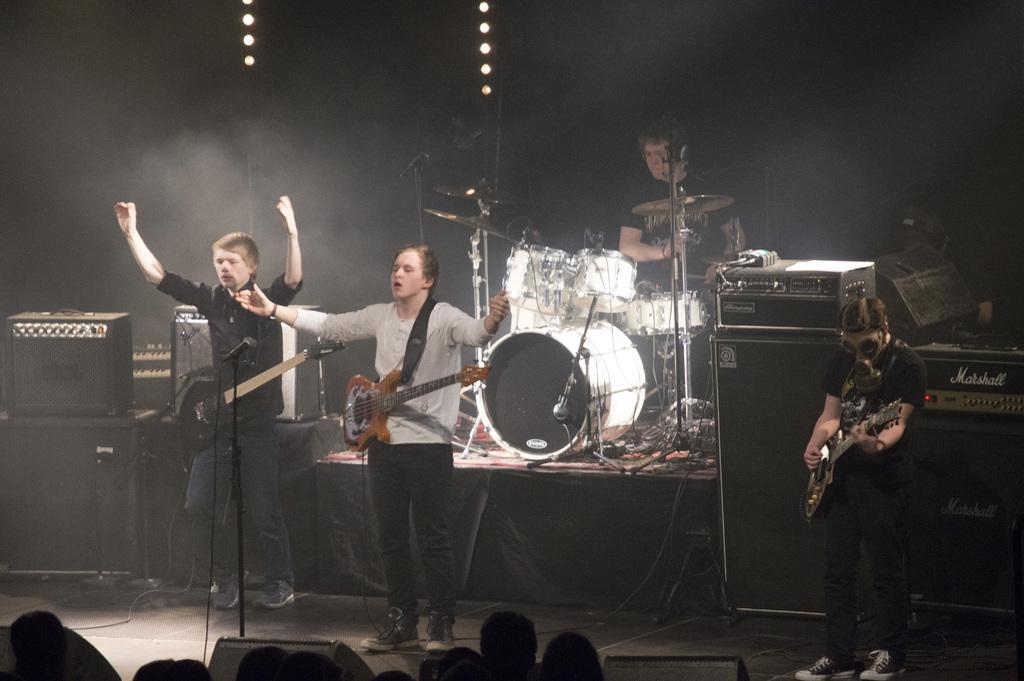Can you describe this image briefly? In the foreground of this image, at the bottom, there are heads of a person and also we can see few black color objects. In the middle, there are two men carrying guitars in front of a mic stand. On the right, there is a man standing and playing guitar. Behind them, there is a man playing drums and also there are electronic devices. In the background, there are lights in the dark. 